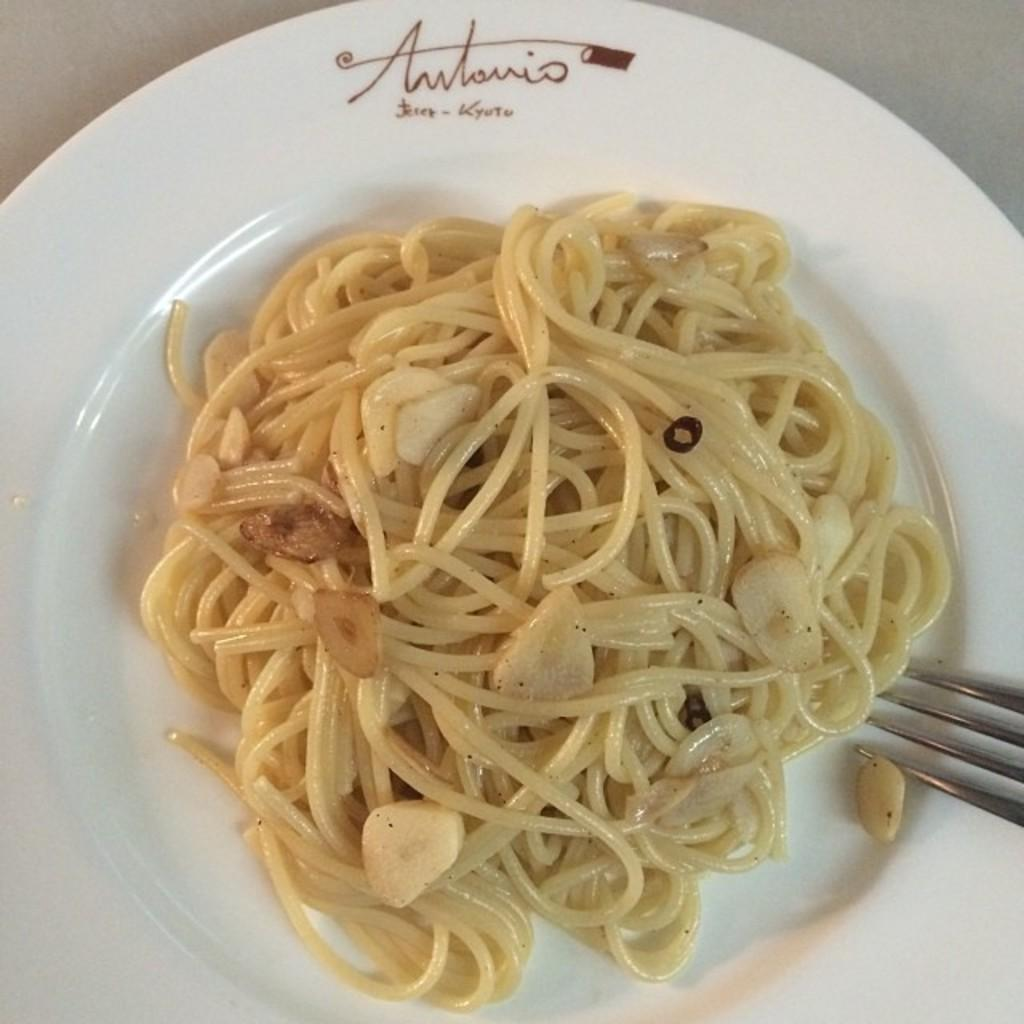What type of food is visible in the image? There are noodles in the image. What is the color of the plate that holds the noodles? The noodles are in a white color plate. What utensil is present in the image? There is a fork in the image. What type of sweater is being worn by the noodles in the image? There is no sweater present in the image, as the subject is a plate of noodles. 